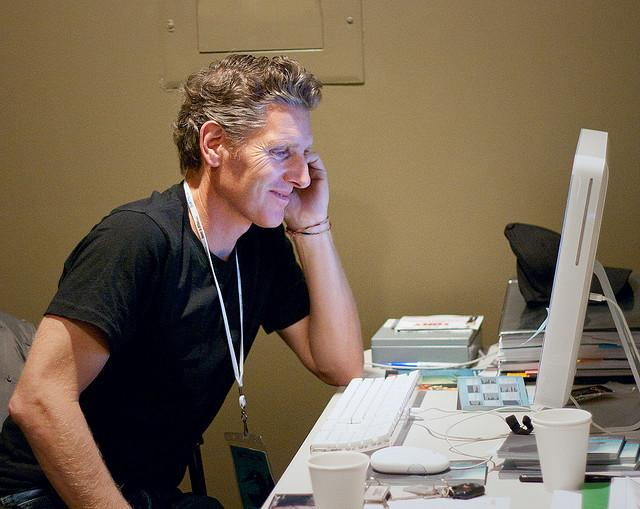What is closest to the computer screen?

Choices:
A) cup
B) nose
C) printer
D) cat cup 